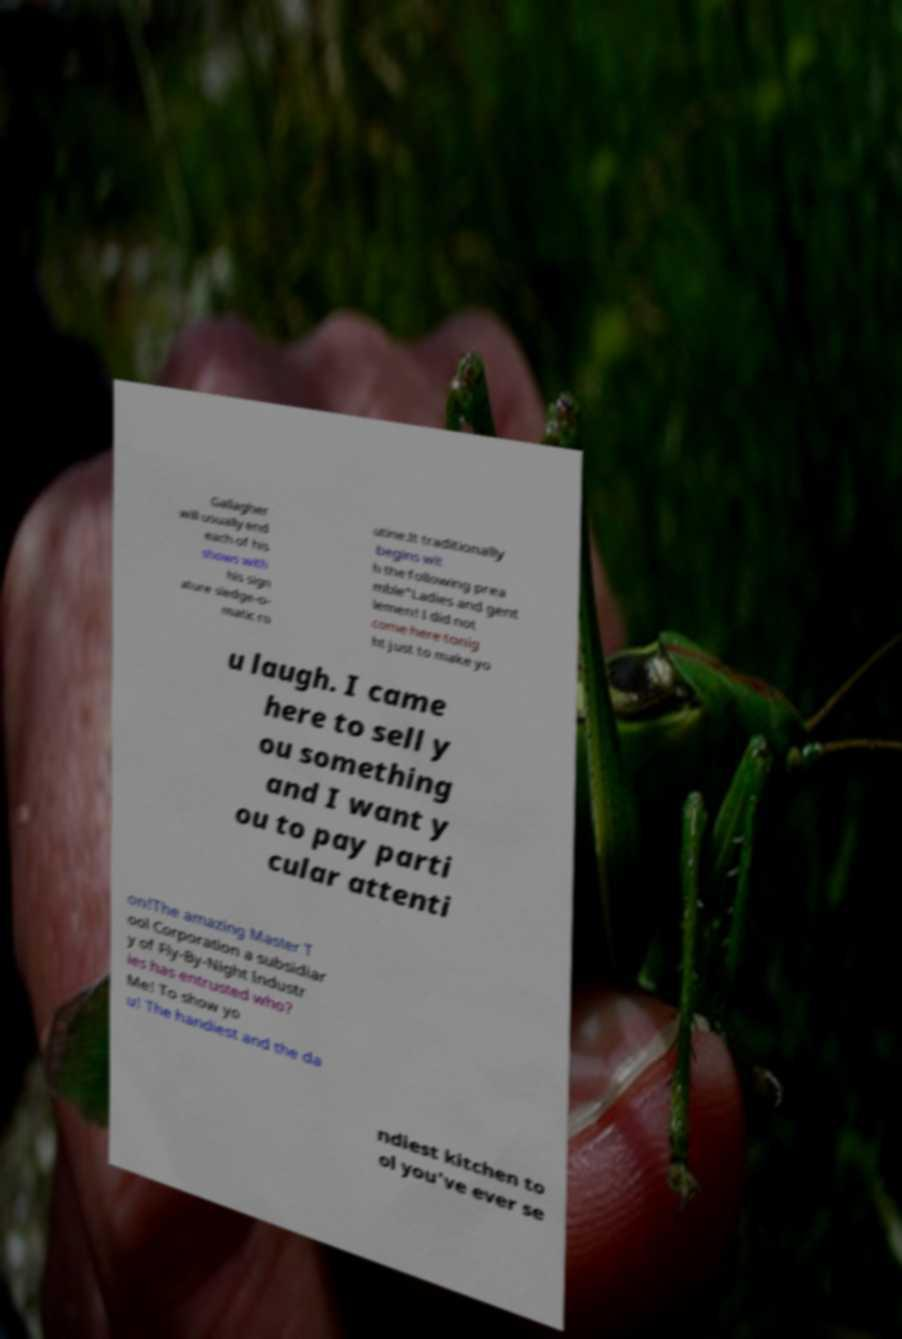Please identify and transcribe the text found in this image. Gallagher will usually end each of his shows with his sign ature sledge-o- matic ro utine.It traditionally begins wit h the following prea mble"Ladies and gent lemen! I did not come here tonig ht just to make yo u laugh. I came here to sell y ou something and I want y ou to pay parti cular attenti on!The amazing Master T ool Corporation a subsidiar y of Fly-By-Night Industr ies has entrusted who? Me! To show yo u! The handiest and the da ndiest kitchen to ol you've ever se 